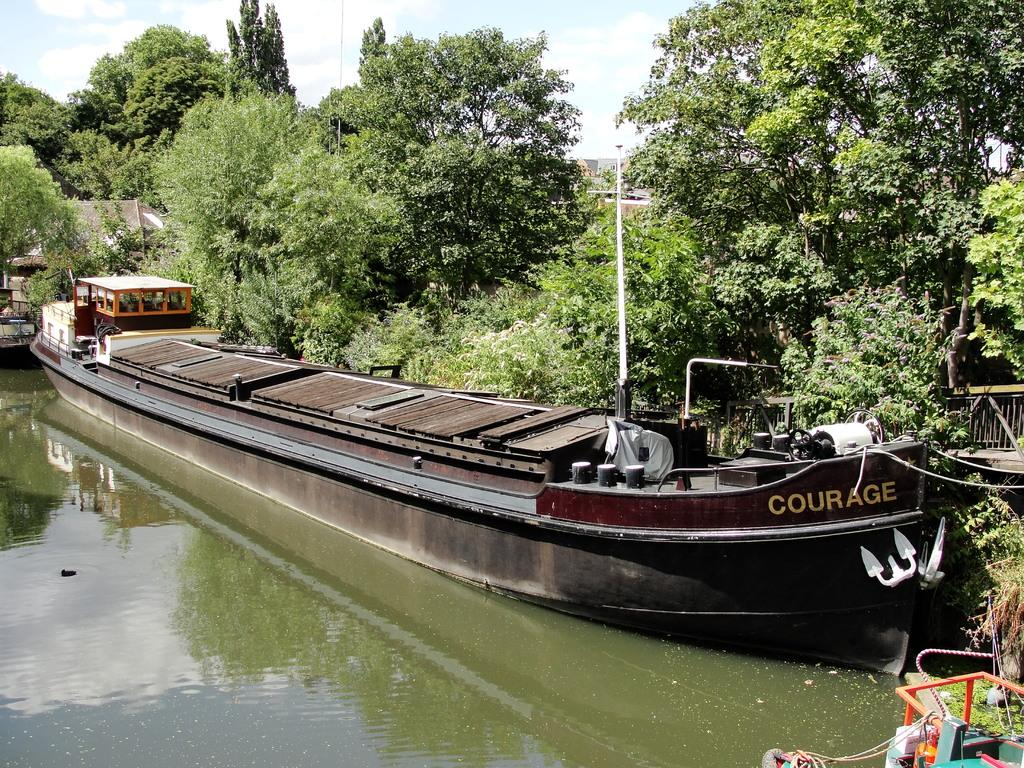What is the main subject of the image? The main subject of the image is boats. Where are the boats located? The boats are on the water. What can be seen in the background of the image? There are trees and the sky visible in the background of the image. What type of party is being held on the boats in the image? There is no indication of a party in the image; it simply shows boats on the water. What system is responsible for the boats' navigation in the image? The image does not provide information about the boats' navigation system. 